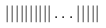Convert formula to latex. <formula><loc_0><loc_0><loc_500><loc_500>| | | | | | | | | | \dots | | | | |</formula> 